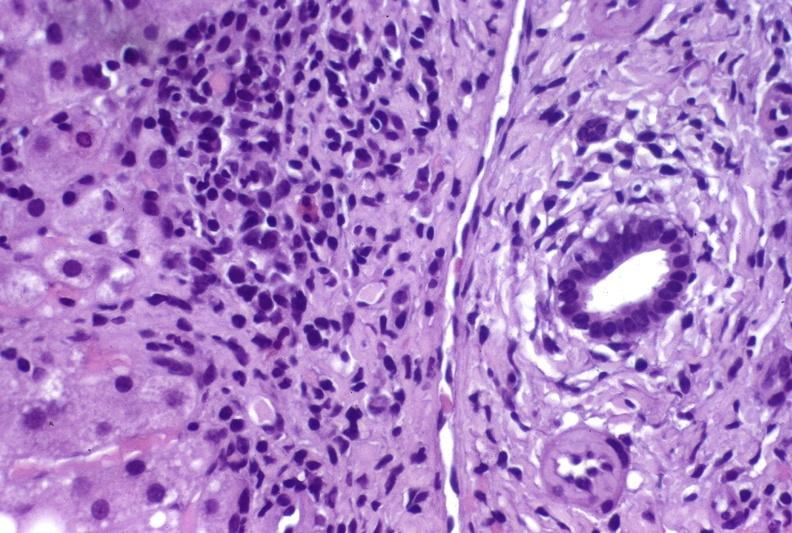s endometritis present?
Answer the question using a single word or phrase. No 